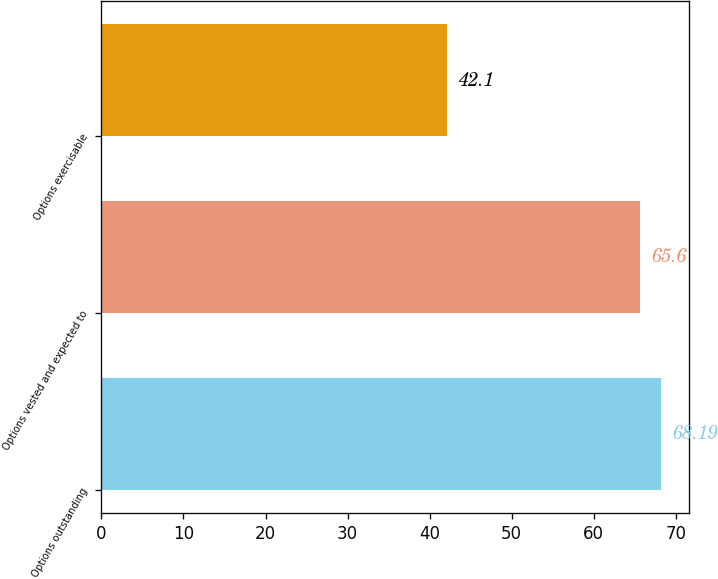<chart> <loc_0><loc_0><loc_500><loc_500><bar_chart><fcel>Options outstanding<fcel>Options vested and expected to<fcel>Options exercisable<nl><fcel>68.19<fcel>65.6<fcel>42.1<nl></chart> 